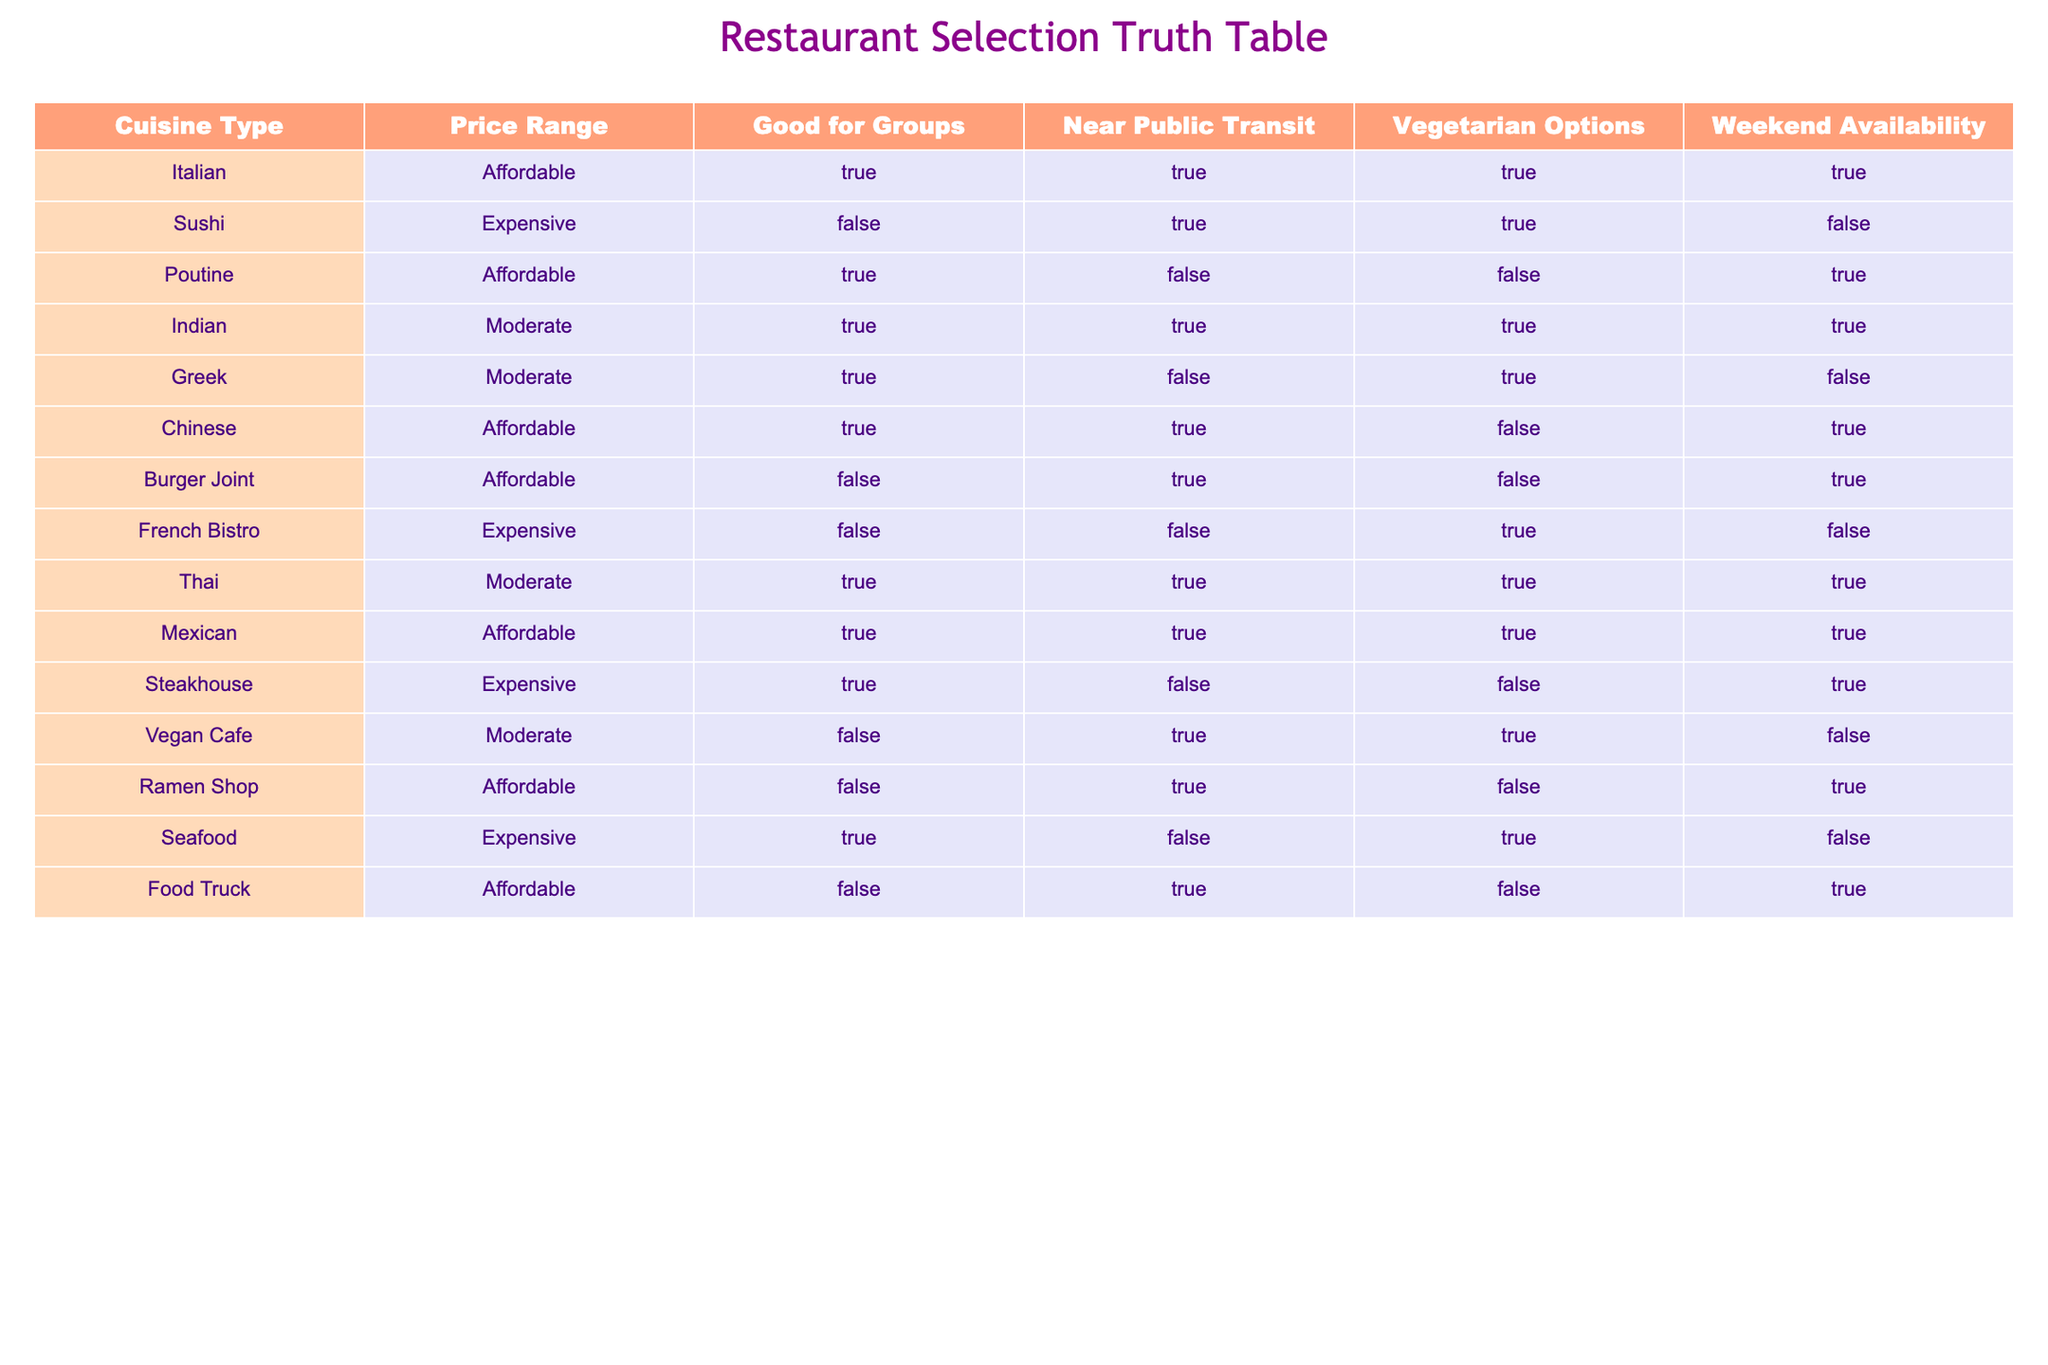What is the price range of the Vegan Cafe? From the table, I can see that the Vegan Cafe has a price range listed as Moderate.
Answer: Moderate Which restaurant has vegetarian options and is also good for groups? I look at the table and find that Indian and Mexican restaurants both have Vegetarian Options marked as TRUE and they are also marked as Good for Groups.
Answer: Indian, Mexican Is there a restaurant that has weekend availability and also vegetarian options? By examining the table, I observe that several restaurants note weekend availability as TRUE and vegetarian options also as TRUE. The Italian, Indian, Thai, and Mexican options meet this criterion.
Answer: Italian, Indian, Thai, Mexican How many restaurants are both moderate in price and good for groups? I count the entries in the table that have a Price Range of Moderate and are also indicated as Good for Groups. The Indian, Greek, and Thai restaurants fit this description, totaling three restaurants.
Answer: 3 Is Sushi a good option for groups? The table indicates that Sushi has a value of FALSE for being Good for Groups.
Answer: No Which cuisine types have vegetarian options and are available on weekends? I check the table for rows marked as having Vegetarian Options as TRUE and Weekend Availability as TRUE. The Italian, Indian, Thai, and Mexican cuisines meet these conditions.
Answer: Italian, Indian, Thai, Mexican What cuisine type is the least expensive? Looking at the Price Range column, the cuisine types categorized as Affordable include Italian, Poutine, Chinese, Burger Joint, Ramen Shop, and Food Truck. While all affordable options are the least expensive, Italian is listed first among them.
Answer: Italian How many expensive restaurants have no vegetarian options? I scan the table for restaurants that are marked as Expensive and note the Vegetarian Options. The Sushi, French Bistro, and Seafood do not provide vegetarian options, giving us a total of three.
Answer: 3 Are there any affordable restaurants that are near public transit? I check the Affordable category and see that Italian, Chinese, Burger Joint, Ramen Shop, and Food Truck are all marked as TRUE for being Near Public Transit.
Answer: Yes, there are five 